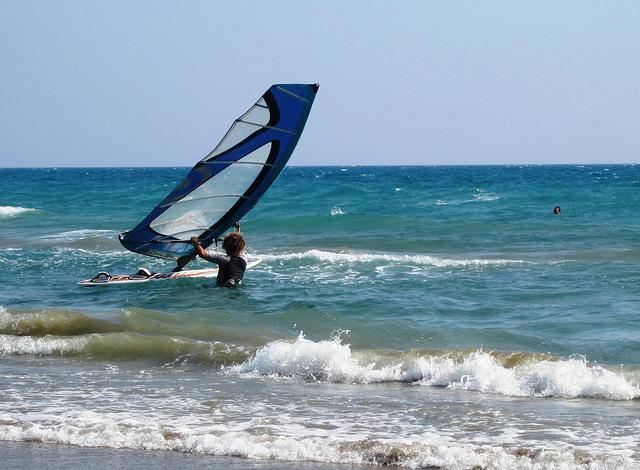What is he doing?

Choices:
A) boarding board
B) sinking
C) taking board
D) falling boarding board 